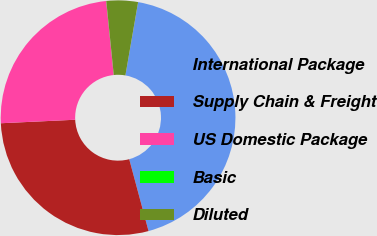<chart> <loc_0><loc_0><loc_500><loc_500><pie_chart><fcel>International Package<fcel>Supply Chain & Freight<fcel>US Domestic Package<fcel>Basic<fcel>Diluted<nl><fcel>43.09%<fcel>28.43%<fcel>24.13%<fcel>0.02%<fcel>4.33%<nl></chart> 